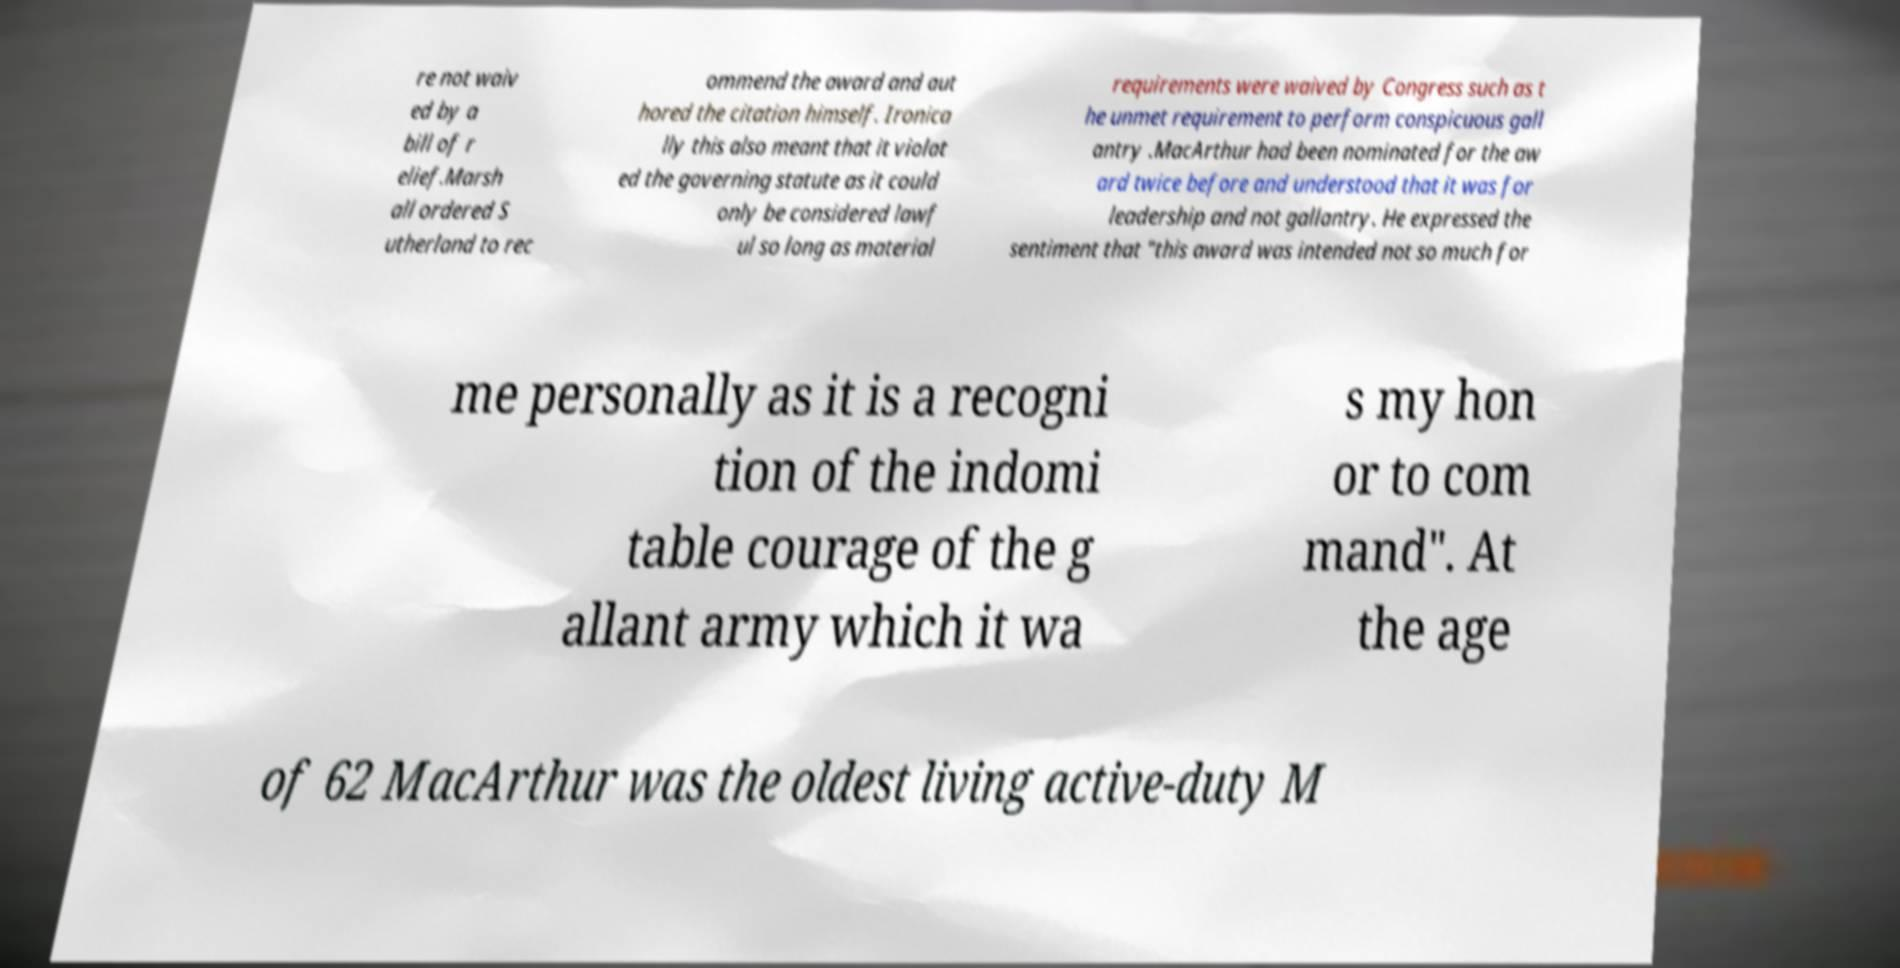Could you extract and type out the text from this image? re not waiv ed by a bill of r elief.Marsh all ordered S utherland to rec ommend the award and aut hored the citation himself. Ironica lly this also meant that it violat ed the governing statute as it could only be considered lawf ul so long as material requirements were waived by Congress such as t he unmet requirement to perform conspicuous gall antry .MacArthur had been nominated for the aw ard twice before and understood that it was for leadership and not gallantry. He expressed the sentiment that "this award was intended not so much for me personally as it is a recogni tion of the indomi table courage of the g allant army which it wa s my hon or to com mand". At the age of 62 MacArthur was the oldest living active-duty M 